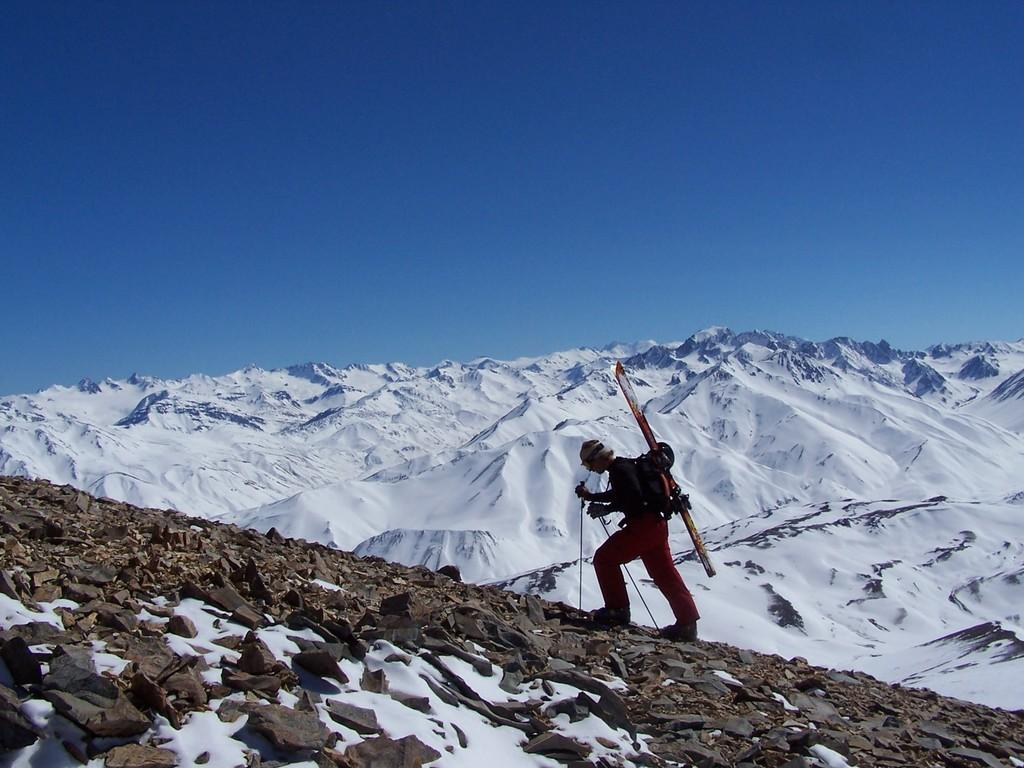Who is in the image? There is a man in the image. What is the man doing in the image? The man is trekking on a mountain. What can be seen around the man? There are rocks around the man. What else can be seen in the distance in the image? There is another mountain visible in the image, and it is covered with snow. What type of eggnog can be seen in the man's hand in the image? There is no eggnog present in the image; the man is trekking on a mountain and does not have any beverages in his hand. 